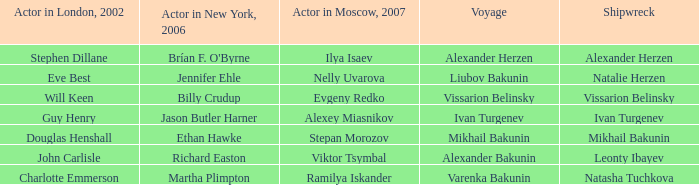Who was the 2007 actor from Moscow for the shipwreck of Leonty Ibayev? Viktor Tsymbal. 